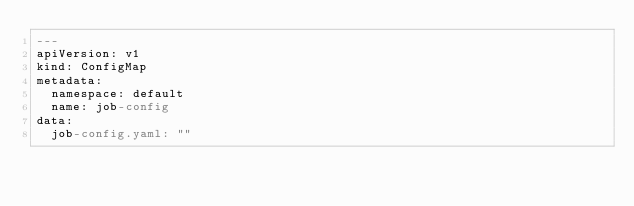<code> <loc_0><loc_0><loc_500><loc_500><_YAML_>---
apiVersion: v1
kind: ConfigMap
metadata:
  namespace: default
  name: job-config
data:
  job-config.yaml: ""
</code> 